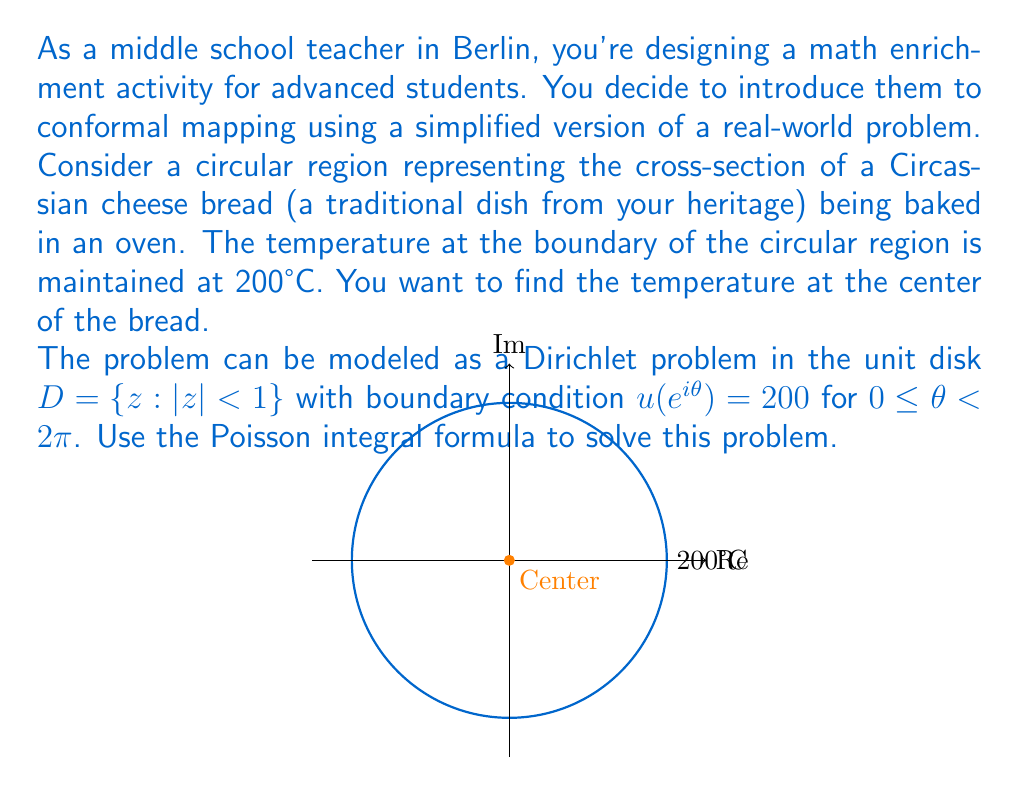Could you help me with this problem? Let's approach this step-by-step:

1) The Poisson integral formula for the unit disk is:

   $$u(z) = \frac{1}{2\pi} \int_0^{2\pi} \frac{1-|z|^2}{|e^{i\theta}-z|^2} u(e^{i\theta}) d\theta$$

2) In our case, $u(e^{i\theta}) = 200$ for all $\theta$, so it's constant and can be taken out of the integral:

   $$u(z) = \frac{200}{2\pi} \int_0^{2\pi} \frac{1-|z|^2}{|e^{i\theta}-z|^2} d\theta$$

3) We want to find the temperature at the center, which means $z = 0$. Substituting this:

   $$u(0) = \frac{200}{2\pi} \int_0^{2\pi} \frac{1-|0|^2}{|e^{i\theta}-0|^2} d\theta$$

4) Simplify:
   $$u(0) = \frac{200}{2\pi} \int_0^{2\pi} \frac{1}{|e^{i\theta}|^2} d\theta = \frac{200}{2\pi} \int_0^{2\pi} 1 d\theta$$

5) Evaluate the integral:
   $$u(0) = \frac{200}{2\pi} [2\pi] = 200$$

Therefore, the temperature at the center of the bread is 200°C, the same as at the boundary.
Answer: 200°C 